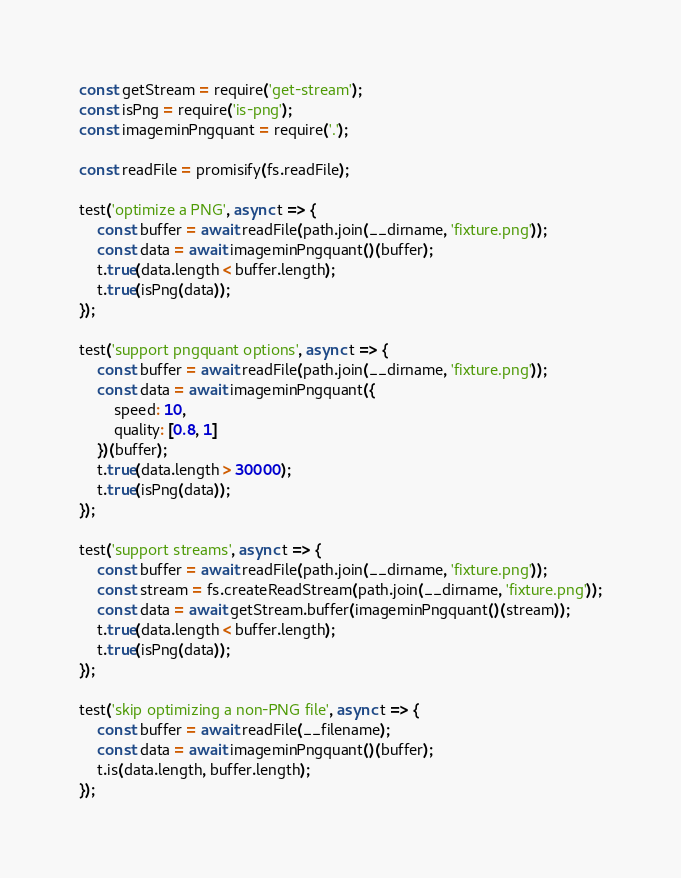<code> <loc_0><loc_0><loc_500><loc_500><_JavaScript_>const getStream = require('get-stream');
const isPng = require('is-png');
const imageminPngquant = require('.');

const readFile = promisify(fs.readFile);

test('optimize a PNG', async t => {
	const buffer = await readFile(path.join(__dirname, 'fixture.png'));
	const data = await imageminPngquant()(buffer);
	t.true(data.length < buffer.length);
	t.true(isPng(data));
});

test('support pngquant options', async t => {
	const buffer = await readFile(path.join(__dirname, 'fixture.png'));
	const data = await imageminPngquant({
		speed: 10,
		quality: [0.8, 1]
	})(buffer);
	t.true(data.length > 30000);
	t.true(isPng(data));
});

test('support streams', async t => {
	const buffer = await readFile(path.join(__dirname, 'fixture.png'));
	const stream = fs.createReadStream(path.join(__dirname, 'fixture.png'));
	const data = await getStream.buffer(imageminPngquant()(stream));
	t.true(data.length < buffer.length);
	t.true(isPng(data));
});

test('skip optimizing a non-PNG file', async t => {
	const buffer = await readFile(__filename);
	const data = await imageminPngquant()(buffer);
	t.is(data.length, buffer.length);
});
</code> 